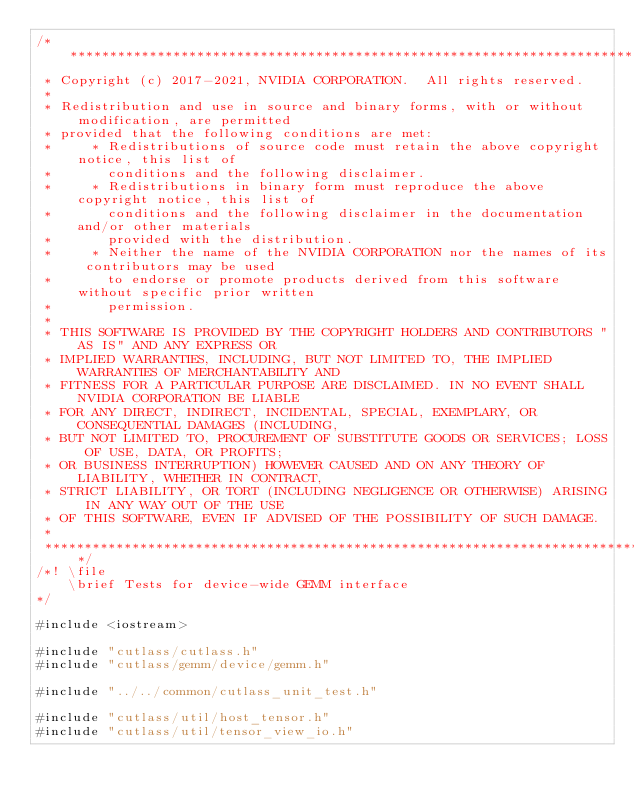<code> <loc_0><loc_0><loc_500><loc_500><_Cuda_>/***************************************************************************************************
 * Copyright (c) 2017-2021, NVIDIA CORPORATION.  All rights reserved.
 *
 * Redistribution and use in source and binary forms, with or without modification, are permitted
 * provided that the following conditions are met:
 *     * Redistributions of source code must retain the above copyright notice, this list of
 *       conditions and the following disclaimer.
 *     * Redistributions in binary form must reproduce the above copyright notice, this list of
 *       conditions and the following disclaimer in the documentation and/or other materials
 *       provided with the distribution.
 *     * Neither the name of the NVIDIA CORPORATION nor the names of its contributors may be used
 *       to endorse or promote products derived from this software without specific prior written
 *       permission.
 *
 * THIS SOFTWARE IS PROVIDED BY THE COPYRIGHT HOLDERS AND CONTRIBUTORS "AS IS" AND ANY EXPRESS OR
 * IMPLIED WARRANTIES, INCLUDING, BUT NOT LIMITED TO, THE IMPLIED WARRANTIES OF MERCHANTABILITY AND
 * FITNESS FOR A PARTICULAR PURPOSE ARE DISCLAIMED. IN NO EVENT SHALL NVIDIA CORPORATION BE LIABLE
 * FOR ANY DIRECT, INDIRECT, INCIDENTAL, SPECIAL, EXEMPLARY, OR CONSEQUENTIAL DAMAGES (INCLUDING,
 * BUT NOT LIMITED TO, PROCUREMENT OF SUBSTITUTE GOODS OR SERVICES; LOSS OF USE, DATA, OR PROFITS;
 * OR BUSINESS INTERRUPTION) HOWEVER CAUSED AND ON ANY THEORY OF LIABILITY, WHETHER IN CONTRACT,
 * STRICT LIABILITY, OR TORT (INCLUDING NEGLIGENCE OR OTHERWISE) ARISING IN ANY WAY OUT OF THE USE
 * OF THIS SOFTWARE, EVEN IF ADVISED OF THE POSSIBILITY OF SUCH DAMAGE.
 *
 **************************************************************************************************/
/*! \file
    \brief Tests for device-wide GEMM interface
*/

#include <iostream>

#include "cutlass/cutlass.h"
#include "cutlass/gemm/device/gemm.h"

#include "../../common/cutlass_unit_test.h"

#include "cutlass/util/host_tensor.h"
#include "cutlass/util/tensor_view_io.h"</code> 